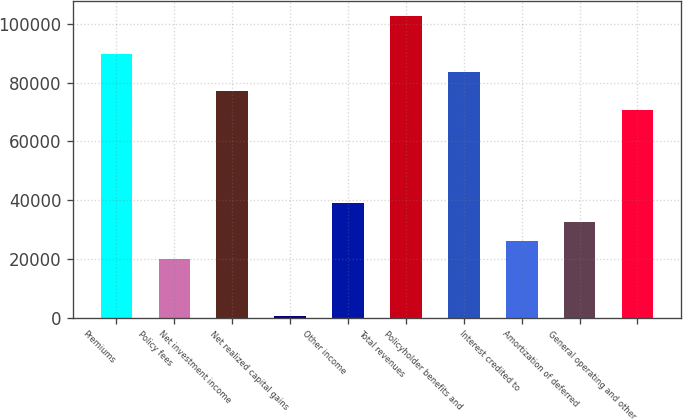<chart> <loc_0><loc_0><loc_500><loc_500><bar_chart><fcel>Premiums<fcel>Policy fees<fcel>Net investment income<fcel>Net realized capital gains<fcel>Other income<fcel>Total revenues<fcel>Policyholder benefits and<fcel>Interest credited to<fcel>Amortization of deferred<fcel>General operating and other<nl><fcel>89872.8<fcel>19839.1<fcel>77139.4<fcel>739<fcel>38939.2<fcel>102606<fcel>83506.1<fcel>26205.8<fcel>32572.5<fcel>70772.7<nl></chart> 